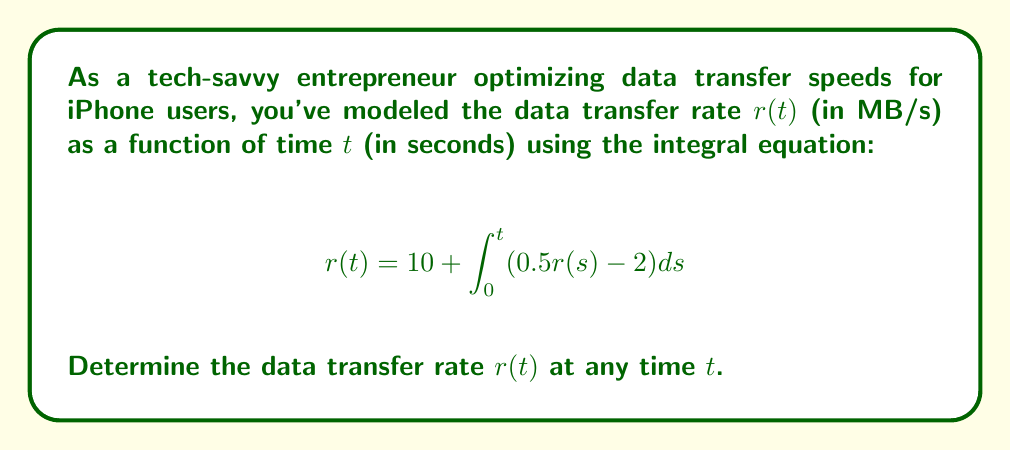Provide a solution to this math problem. Let's solve this integral equation step-by-step:

1) First, we recognize this as a Volterra integral equation of the second kind.

2) To solve it, we'll differentiate both sides with respect to $t$:

   $$\frac{d}{dt}r(t) = \frac{d}{dt}\left(10 + \int_0^t (0.5r(s) - 2) ds\right)$$

3) Using the Fundamental Theorem of Calculus:

   $$\frac{dr}{dt} = 0.5r(t) - 2$$

4) This is now a first-order linear differential equation. We can rearrange it:

   $$\frac{dr}{dt} - 0.5r = -2$$

5) The general solution to this equation is:

   $$r(t) = Ce^{0.5t} + 4$$

   where $C$ is a constant to be determined.

6) To find $C$, we use the initial condition. At $t=0$, from the original equation:

   $$r(0) = 10 + \int_0^0 (0.5r(s) - 2) ds = 10$$

7) Substituting this into our general solution:

   $$10 = Ce^{0\cdot0.5} + 4$$
   $$10 = C + 4$$
   $$C = 6$$

8) Therefore, the final solution is:

   $$r(t) = 6e^{0.5t} + 4$$

This represents the data transfer rate at any time $t$.
Answer: $r(t) = 6e^{0.5t} + 4$ 